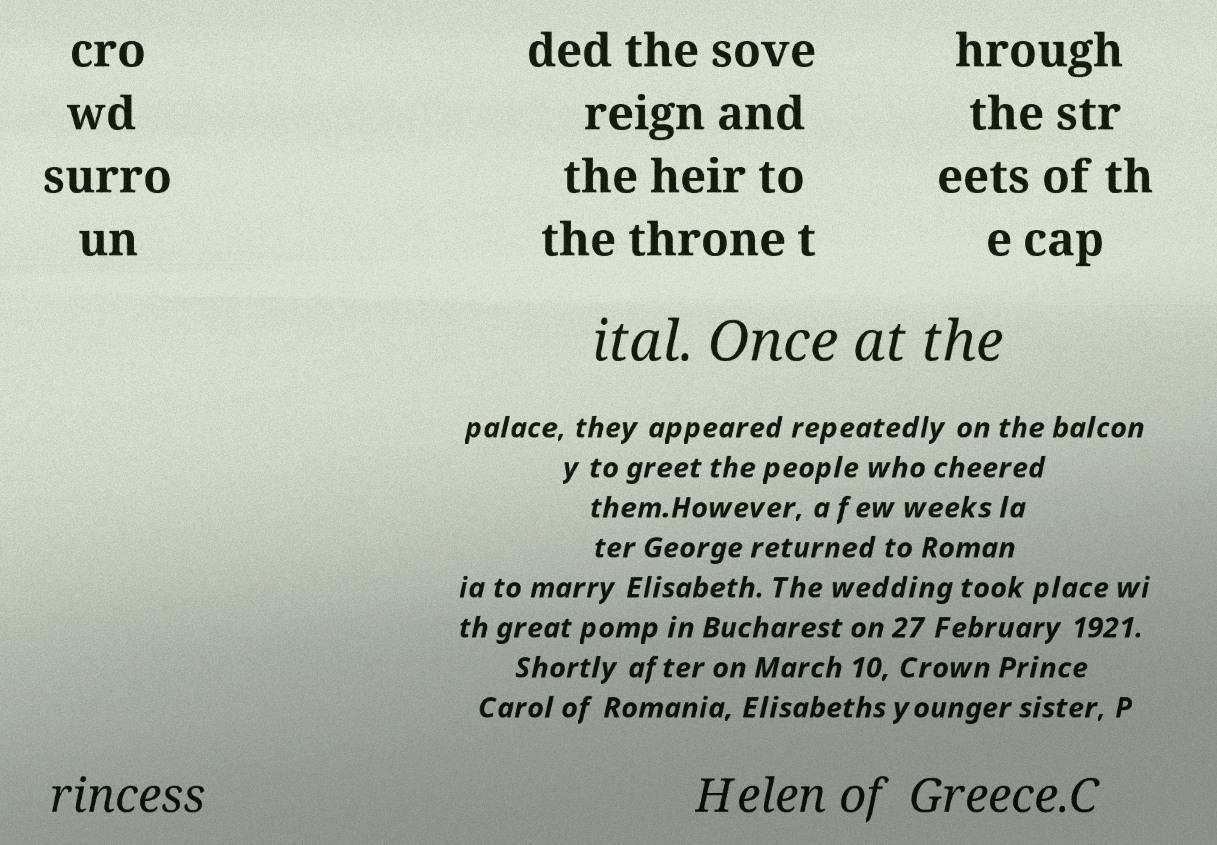Can you accurately transcribe the text from the provided image for me? cro wd surro un ded the sove reign and the heir to the throne t hrough the str eets of th e cap ital. Once at the palace, they appeared repeatedly on the balcon y to greet the people who cheered them.However, a few weeks la ter George returned to Roman ia to marry Elisabeth. The wedding took place wi th great pomp in Bucharest on 27 February 1921. Shortly after on March 10, Crown Prince Carol of Romania, Elisabeths younger sister, P rincess Helen of Greece.C 